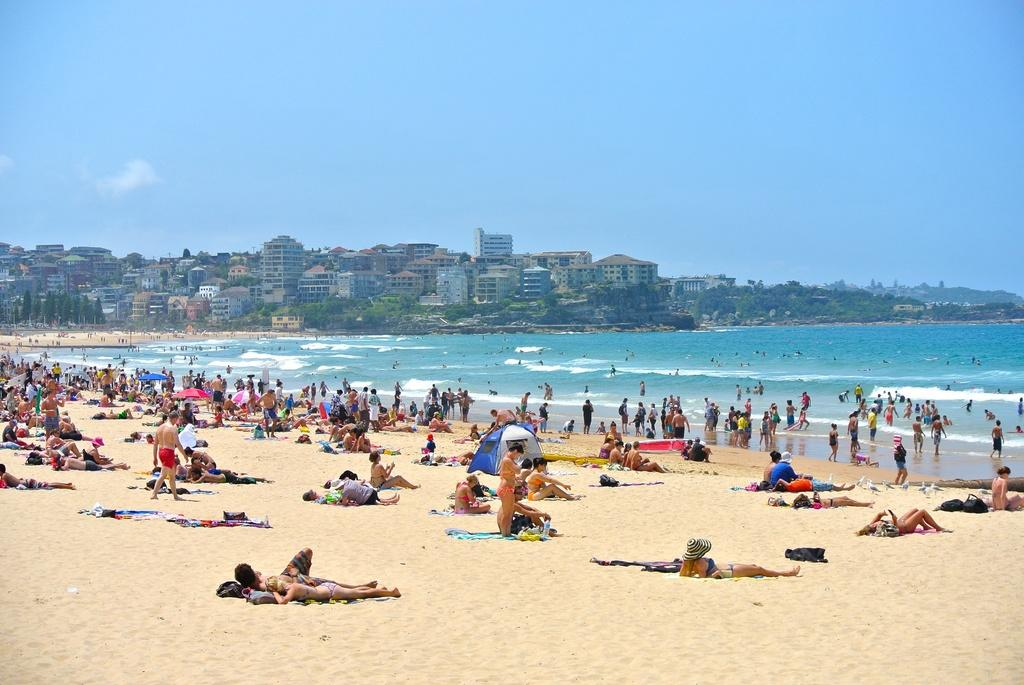How many people are in the image? There are people in the image, but the exact number is not specified. What type of shelter is visible in the image? There is a tent in the image. What type of terrain is present in the image? There is sand in the image. What natural element is present in the image? There is water in the image. What type of shade is provided in the image? There are umbrellas in the image. What can be seen in the background of the image? There are buildings, trees, and the sky visible in the background of the image. What type of request is being made in the image? There is no indication of any request being made in the image. What type of trade is being conducted in the image? There is no indication of any trade being conducted in the image. 